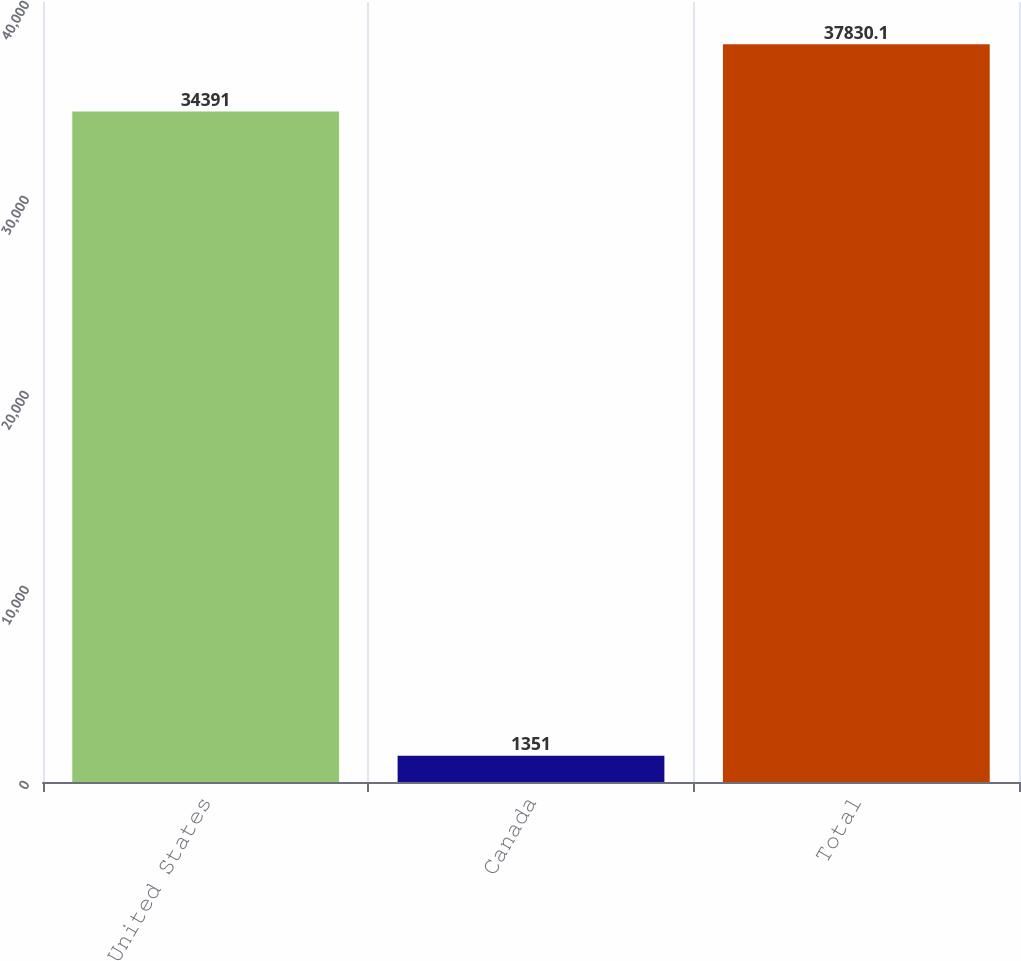<chart> <loc_0><loc_0><loc_500><loc_500><bar_chart><fcel>United States<fcel>Canada<fcel>Total<nl><fcel>34391<fcel>1351<fcel>37830.1<nl></chart> 